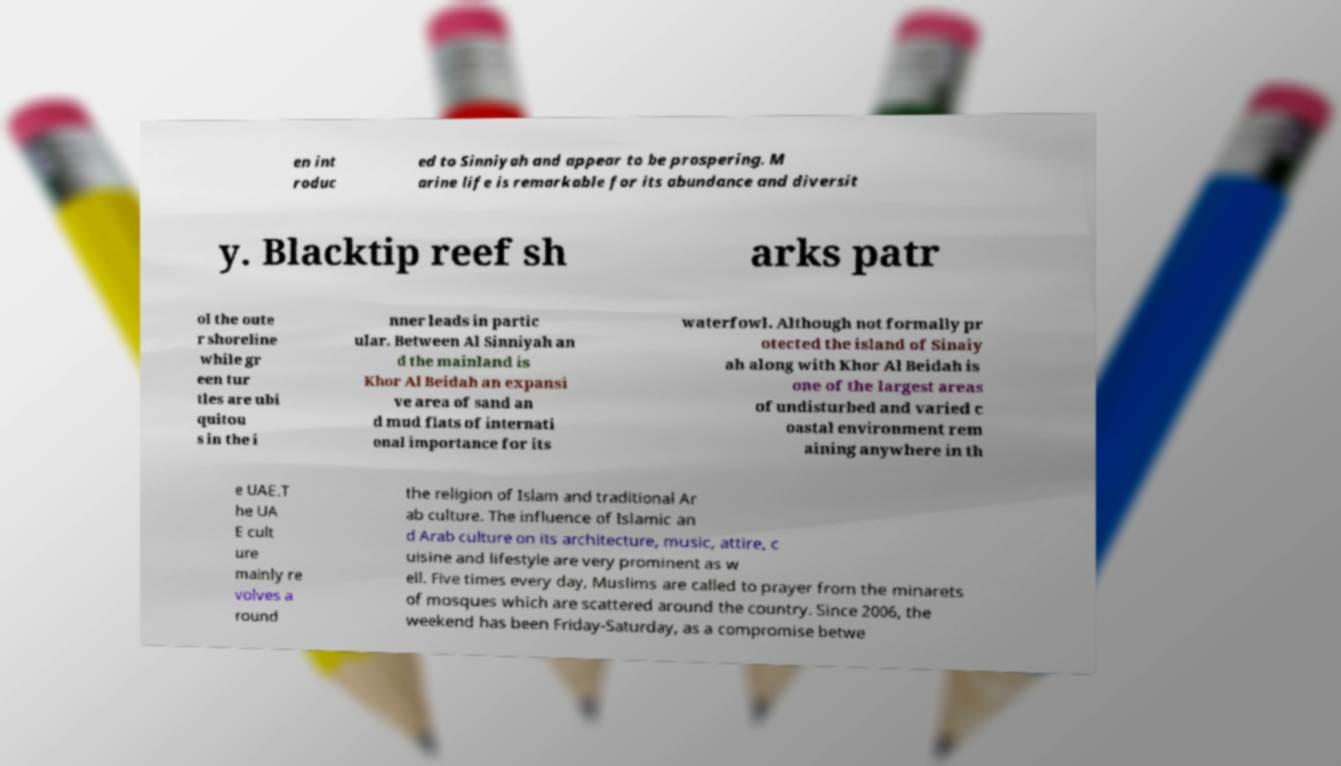Please read and relay the text visible in this image. What does it say? en int roduc ed to Sinniyah and appear to be prospering. M arine life is remarkable for its abundance and diversit y. Blacktip reef sh arks patr ol the oute r shoreline while gr een tur tles are ubi quitou s in the i nner leads in partic ular. Between Al Sinniyah an d the mainland is Khor Al Beidah an expansi ve area of sand an d mud flats of internati onal importance for its waterfowl. Although not formally pr otected the island of Sinaiy ah along with Khor Al Beidah is one of the largest areas of undisturbed and varied c oastal environment rem aining anywhere in th e UAE.T he UA E cult ure mainly re volves a round the religion of Islam and traditional Ar ab culture. The influence of Islamic an d Arab culture on its architecture, music, attire, c uisine and lifestyle are very prominent as w ell. Five times every day, Muslims are called to prayer from the minarets of mosques which are scattered around the country. Since 2006, the weekend has been Friday-Saturday, as a compromise betwe 